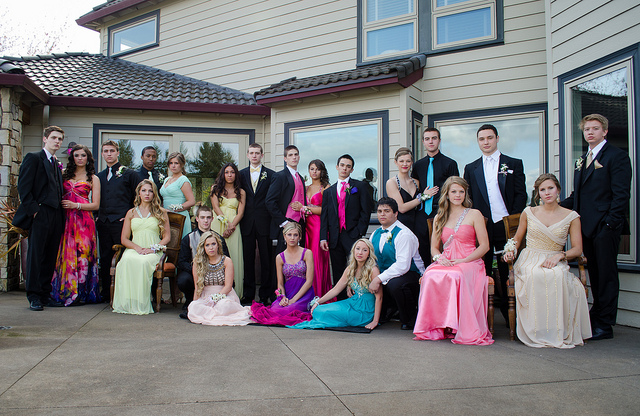<image>What type of wedding dress is this woman wearing? I am not sure what type of wedding dress the woman is wearing. The dress could be white or pink, and could be long and sleeveless. What type of wedding dress is this woman wearing? I don't know what type of wedding dress this woman is wearing. It can be white, pink, sleeveless, strap, long, elegant or none prom dresses. 